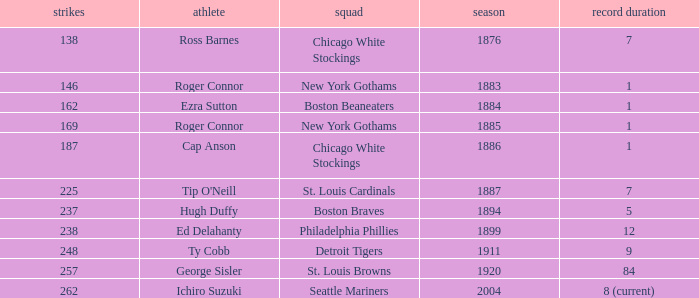Name the least hits for year less than 1920 and player of ed delahanty 238.0. 